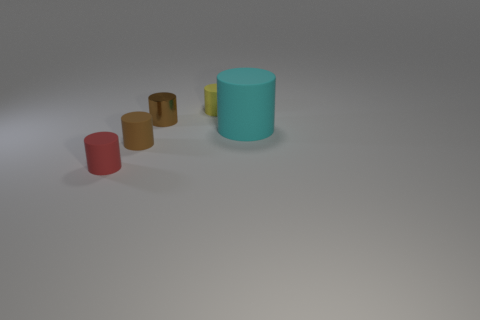Subtract all brown matte cylinders. How many cylinders are left? 4 Add 1 tiny purple shiny objects. How many objects exist? 6 Subtract all yellow cylinders. How many cylinders are left? 4 Subtract 2 cylinders. How many cylinders are left? 3 Subtract all green cylinders. Subtract all brown spheres. How many cylinders are left? 5 Subtract all gray spheres. How many cyan cylinders are left? 1 Subtract all yellow matte cylinders. Subtract all brown rubber things. How many objects are left? 3 Add 3 small matte cylinders. How many small matte cylinders are left? 6 Add 2 small brown metal cylinders. How many small brown metal cylinders exist? 3 Subtract 0 cyan spheres. How many objects are left? 5 